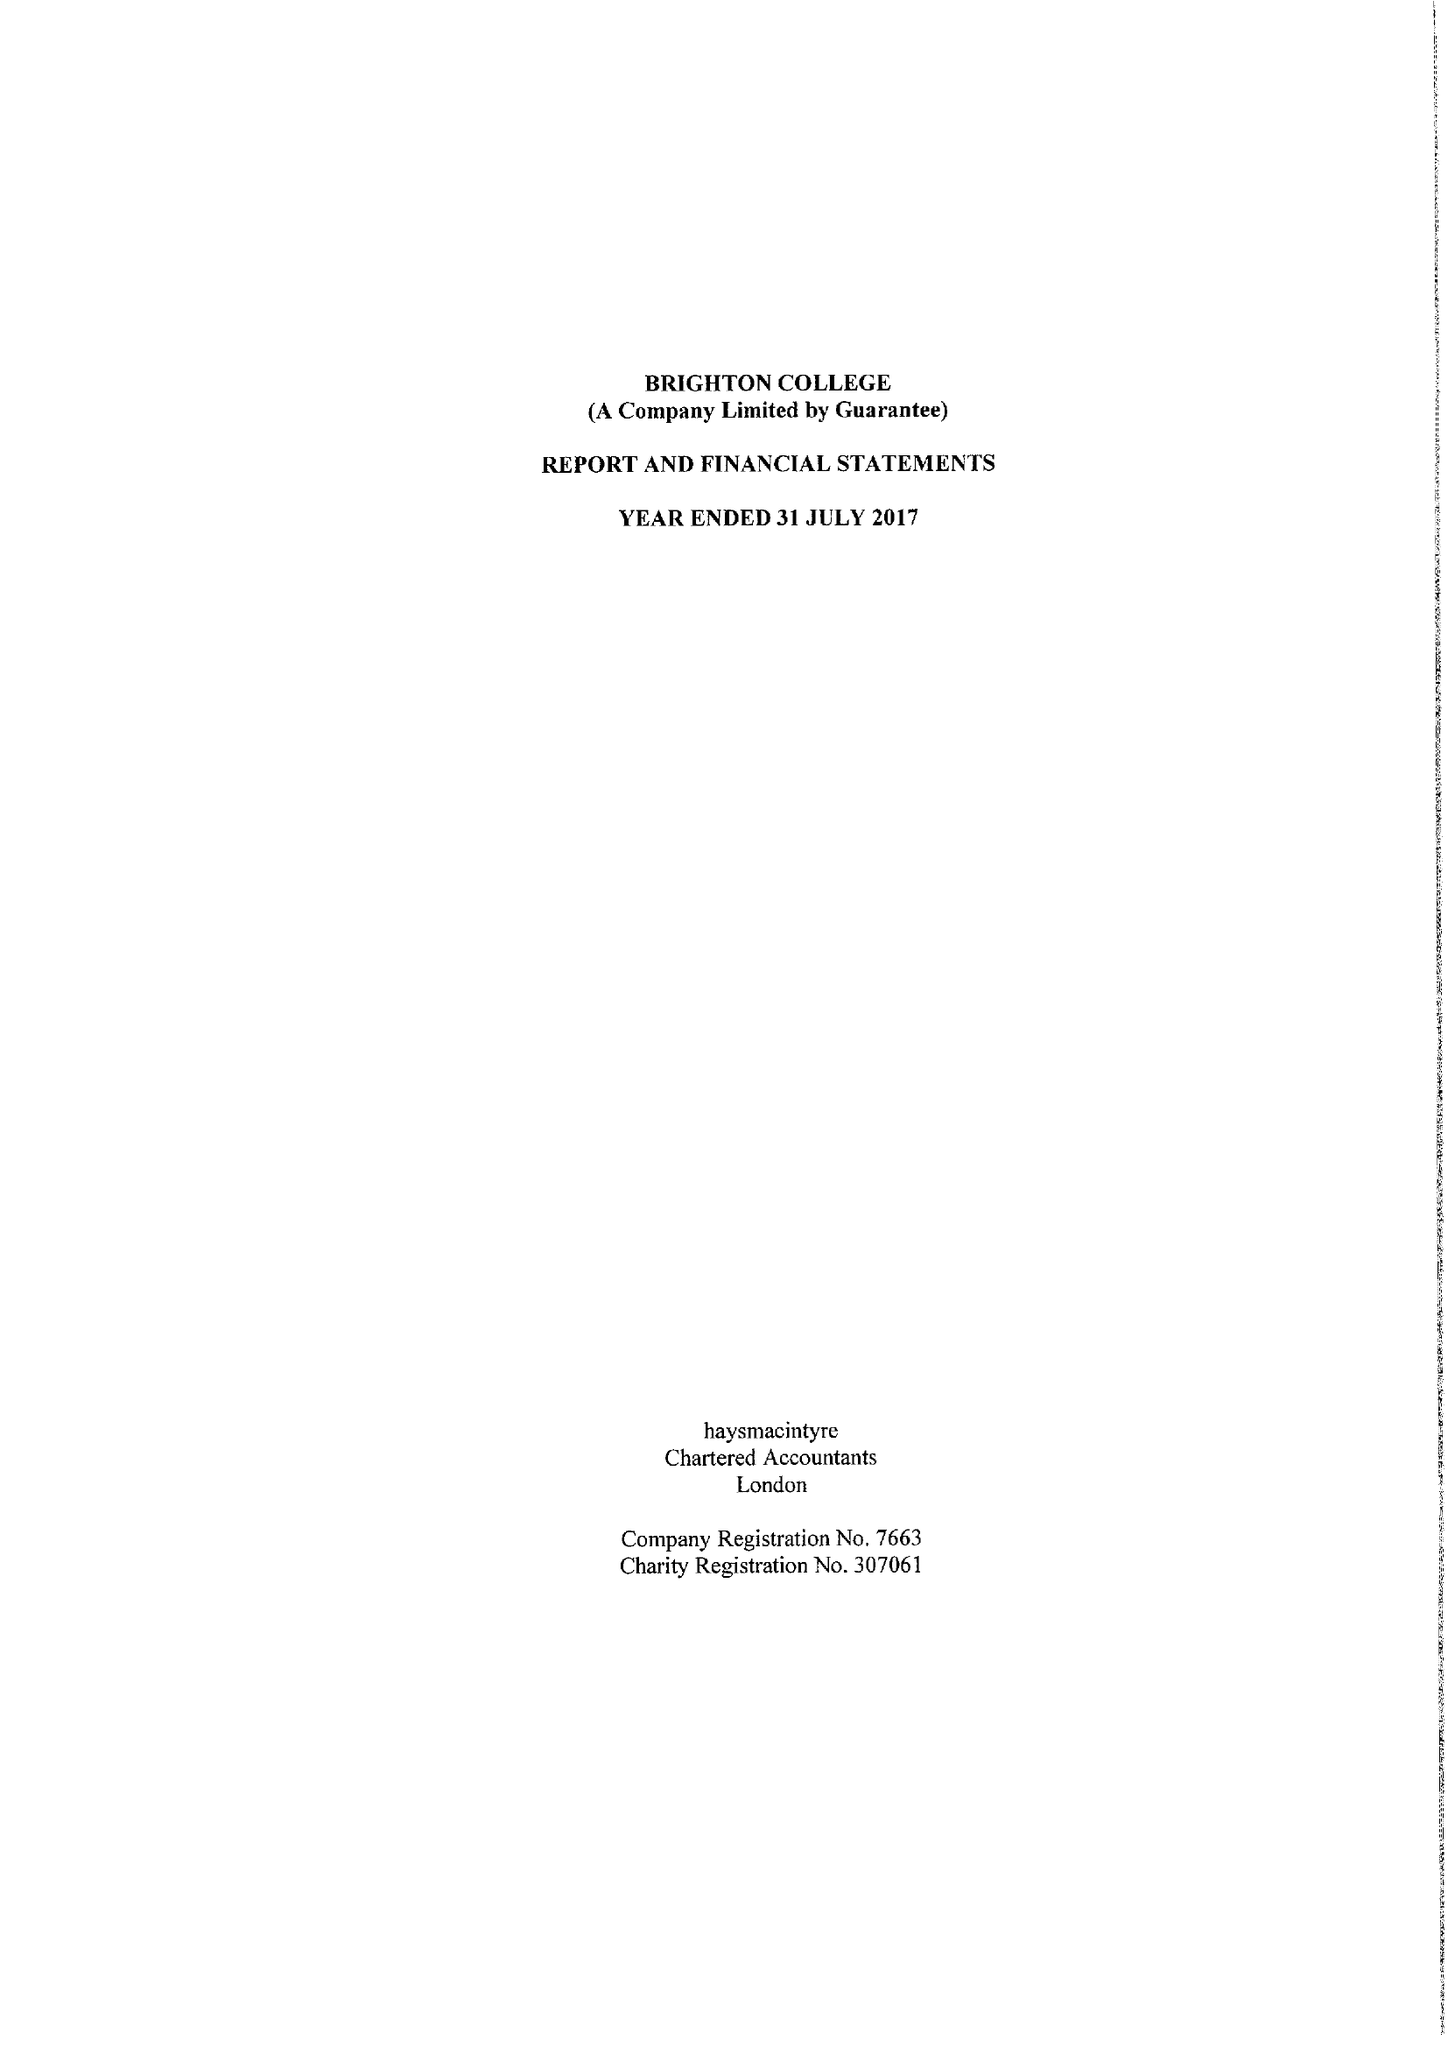What is the value for the charity_number?
Answer the question using a single word or phrase. 307061 